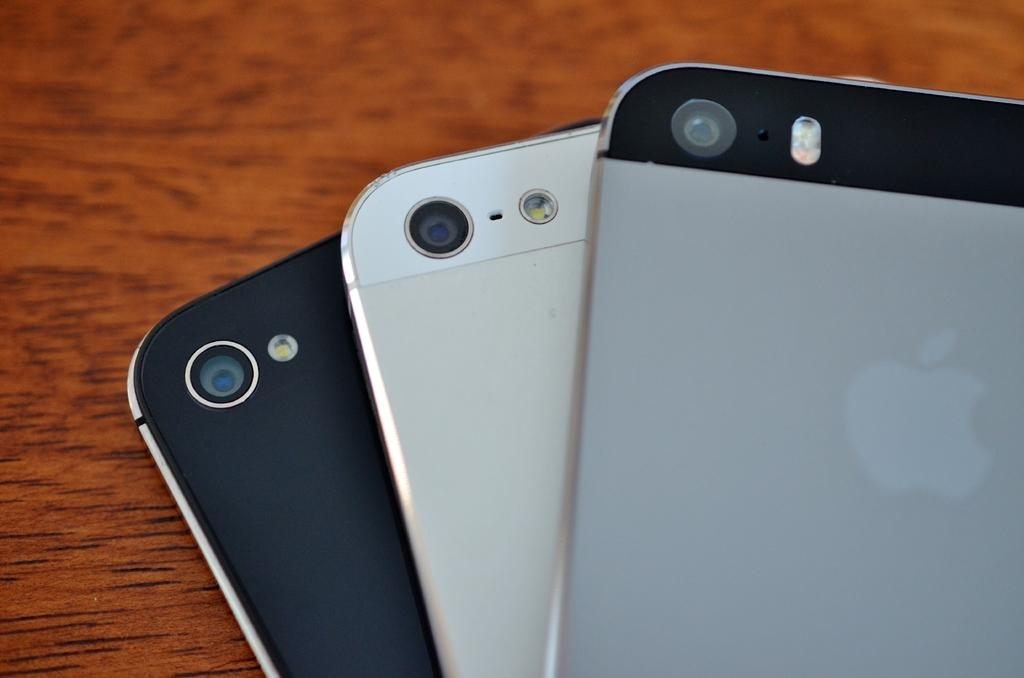How many phones are visible in the image? There are three phones in the image. Where are the phones located? The phones are on a wooden desk. What type of whip is being used to control the phones in the image? There is no whip or control mechanism present in the image; the phones are simply placed on the wooden desk. 